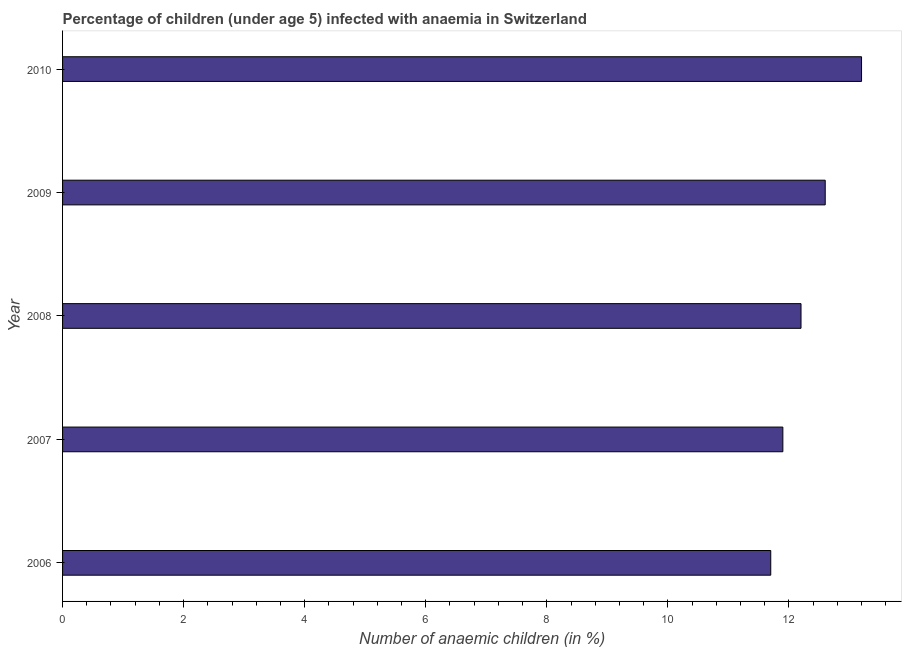Does the graph contain grids?
Ensure brevity in your answer.  No. What is the title of the graph?
Give a very brief answer. Percentage of children (under age 5) infected with anaemia in Switzerland. What is the label or title of the X-axis?
Ensure brevity in your answer.  Number of anaemic children (in %). What is the number of anaemic children in 2007?
Your answer should be compact. 11.9. Across all years, what is the maximum number of anaemic children?
Keep it short and to the point. 13.2. Across all years, what is the minimum number of anaemic children?
Your response must be concise. 11.7. In which year was the number of anaemic children maximum?
Offer a very short reply. 2010. What is the sum of the number of anaemic children?
Offer a very short reply. 61.6. What is the difference between the number of anaemic children in 2008 and 2009?
Make the answer very short. -0.4. What is the average number of anaemic children per year?
Your answer should be very brief. 12.32. In how many years, is the number of anaemic children greater than 2.4 %?
Provide a short and direct response. 5. Do a majority of the years between 2008 and 2010 (inclusive) have number of anaemic children greater than 12.8 %?
Offer a very short reply. No. What is the ratio of the number of anaemic children in 2006 to that in 2009?
Your response must be concise. 0.93. What is the difference between the highest and the second highest number of anaemic children?
Your response must be concise. 0.6. In how many years, is the number of anaemic children greater than the average number of anaemic children taken over all years?
Provide a succinct answer. 2. How many years are there in the graph?
Give a very brief answer. 5. What is the difference between two consecutive major ticks on the X-axis?
Make the answer very short. 2. Are the values on the major ticks of X-axis written in scientific E-notation?
Make the answer very short. No. What is the Number of anaemic children (in %) in 2007?
Offer a very short reply. 11.9. What is the Number of anaemic children (in %) in 2008?
Keep it short and to the point. 12.2. What is the difference between the Number of anaemic children (in %) in 2006 and 2007?
Offer a terse response. -0.2. What is the difference between the Number of anaemic children (in %) in 2006 and 2008?
Ensure brevity in your answer.  -0.5. What is the difference between the Number of anaemic children (in %) in 2008 and 2009?
Offer a very short reply. -0.4. What is the difference between the Number of anaemic children (in %) in 2009 and 2010?
Your answer should be very brief. -0.6. What is the ratio of the Number of anaemic children (in %) in 2006 to that in 2007?
Provide a short and direct response. 0.98. What is the ratio of the Number of anaemic children (in %) in 2006 to that in 2008?
Keep it short and to the point. 0.96. What is the ratio of the Number of anaemic children (in %) in 2006 to that in 2009?
Offer a very short reply. 0.93. What is the ratio of the Number of anaemic children (in %) in 2006 to that in 2010?
Your answer should be very brief. 0.89. What is the ratio of the Number of anaemic children (in %) in 2007 to that in 2008?
Your answer should be very brief. 0.97. What is the ratio of the Number of anaemic children (in %) in 2007 to that in 2009?
Offer a very short reply. 0.94. What is the ratio of the Number of anaemic children (in %) in 2007 to that in 2010?
Ensure brevity in your answer.  0.9. What is the ratio of the Number of anaemic children (in %) in 2008 to that in 2009?
Provide a succinct answer. 0.97. What is the ratio of the Number of anaemic children (in %) in 2008 to that in 2010?
Ensure brevity in your answer.  0.92. What is the ratio of the Number of anaemic children (in %) in 2009 to that in 2010?
Offer a terse response. 0.95. 